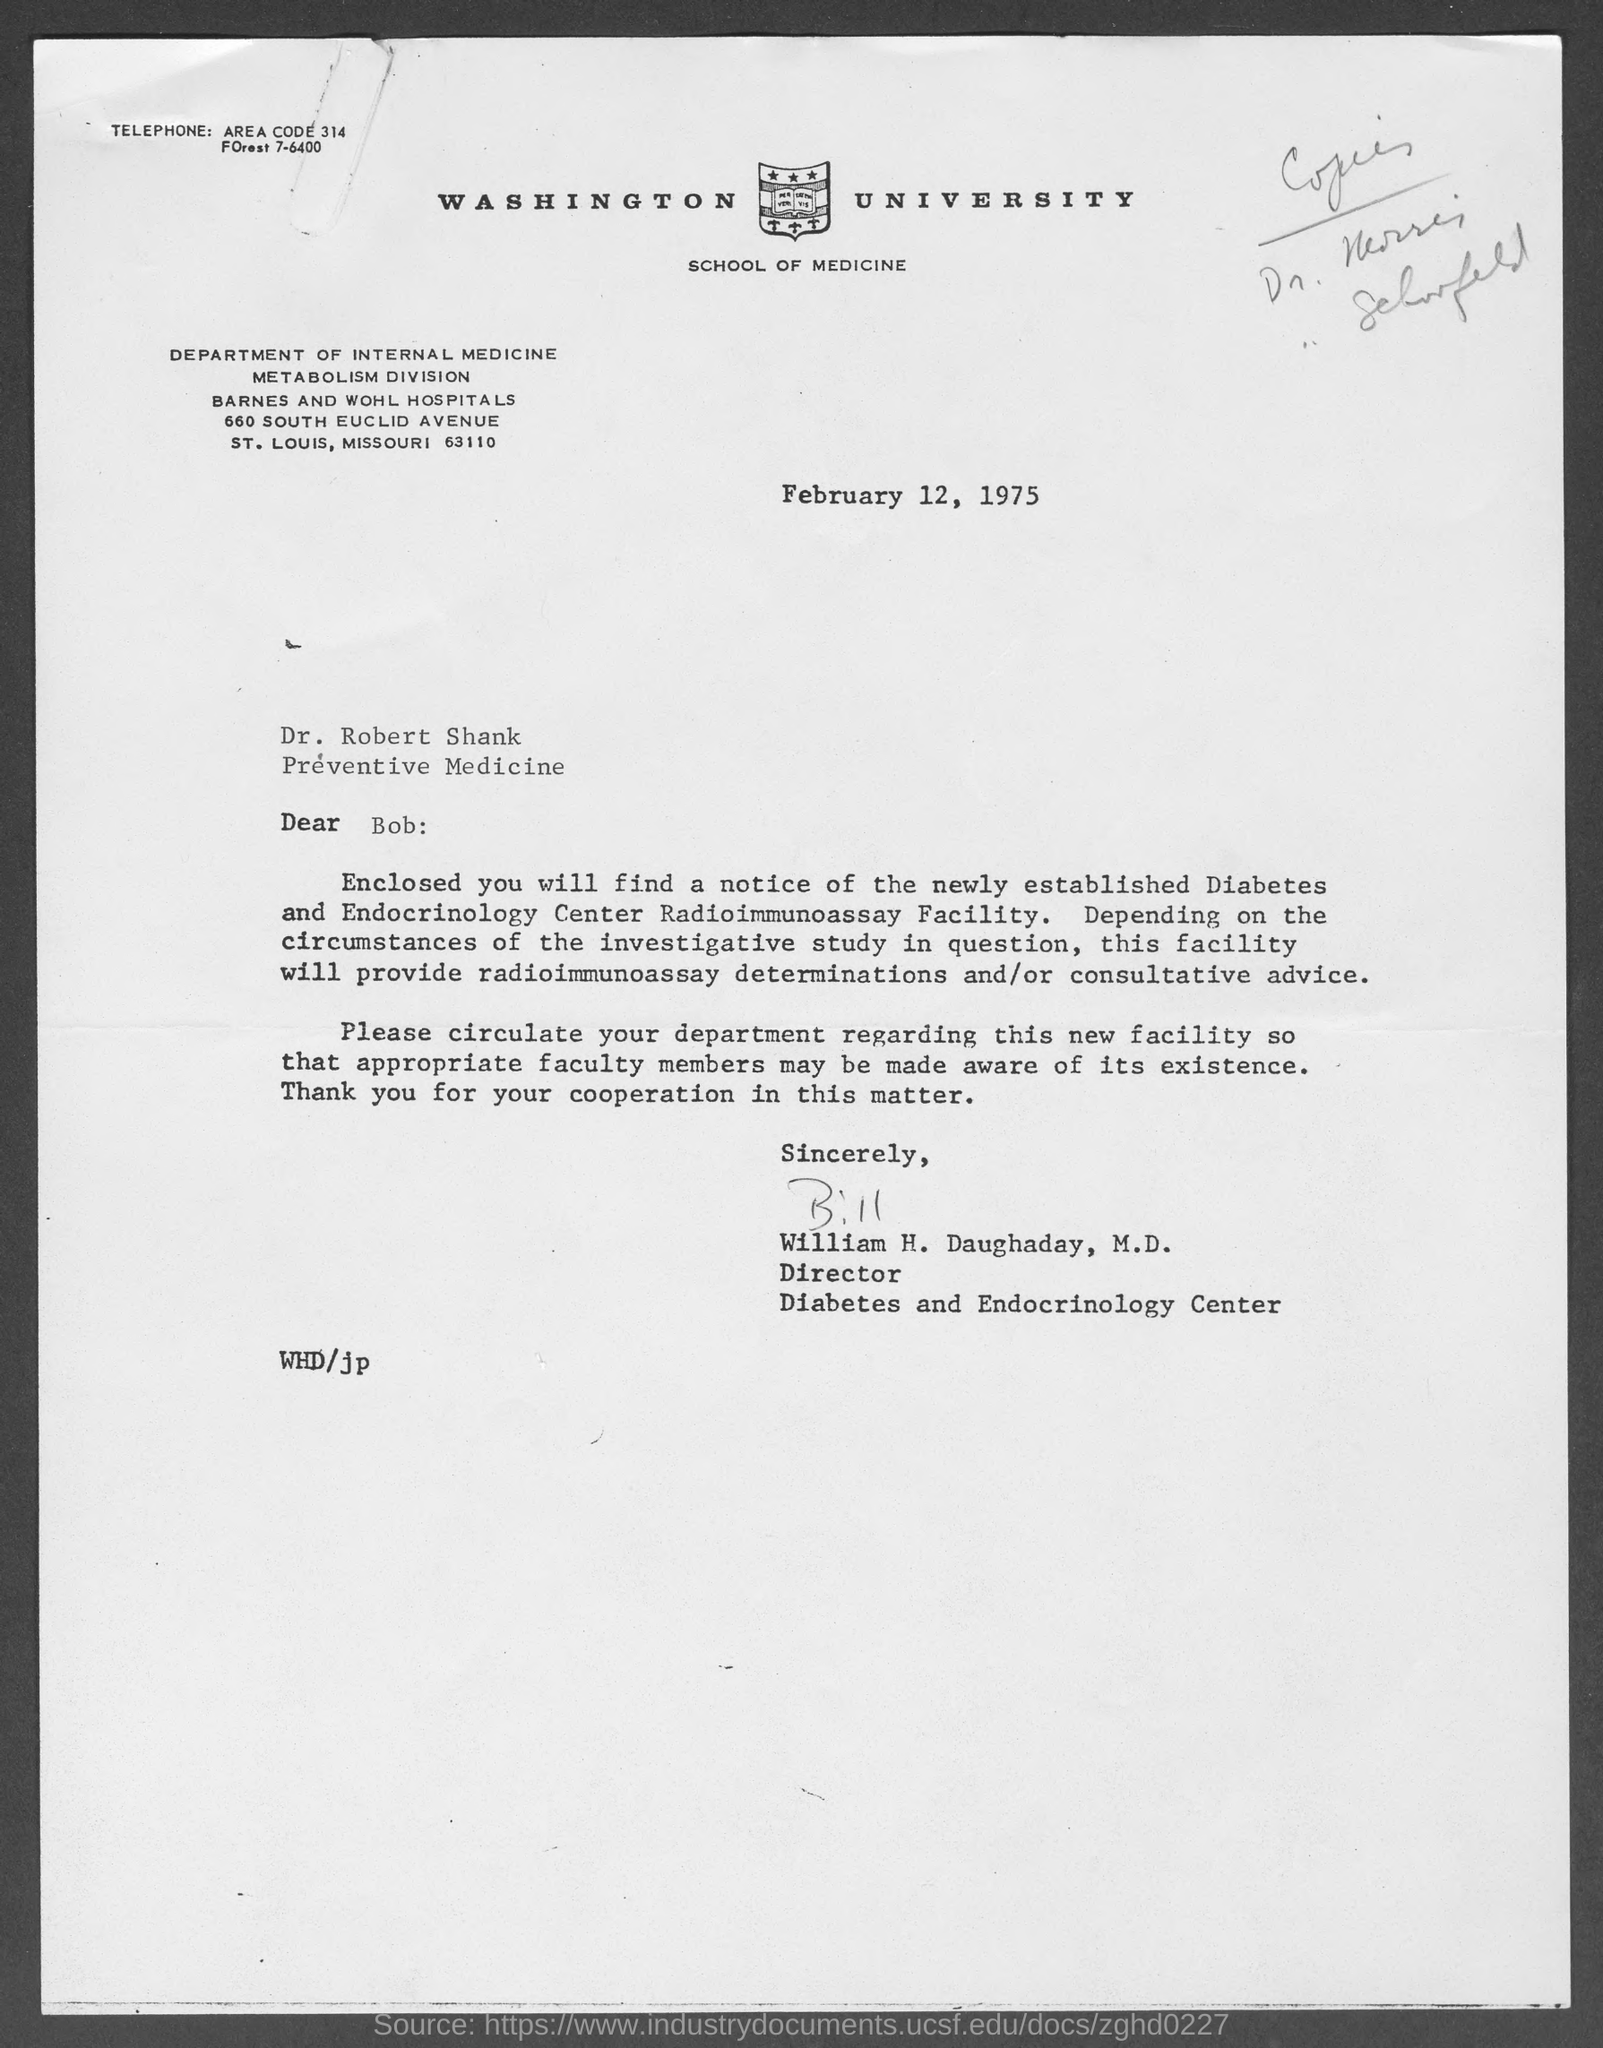What is the date on the document?
Offer a very short reply. February 12, 1975. To Whom is this letter addressed to?
Your answer should be compact. Dr. Robert Shank. Who is this letter from?
Ensure brevity in your answer.  William H. Daughaday. 